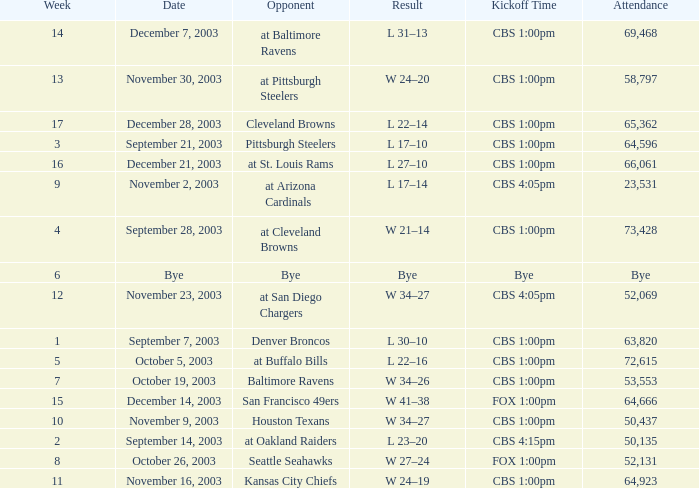What was the kickoff time on week 1? CBS 1:00pm. 